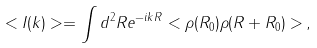Convert formula to latex. <formula><loc_0><loc_0><loc_500><loc_500>< I ( { k } ) > = \int d ^ { 2 } { R } e ^ { - i { k } { R } } < \rho ( { R } _ { 0 } ) \rho ( { R } + { R } _ { 0 } ) > \, ,</formula> 